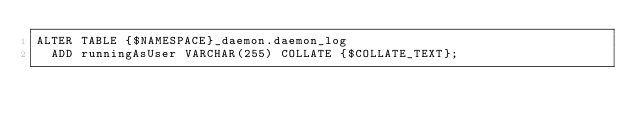<code> <loc_0><loc_0><loc_500><loc_500><_SQL_>ALTER TABLE {$NAMESPACE}_daemon.daemon_log
  ADD runningAsUser VARCHAR(255) COLLATE {$COLLATE_TEXT};
</code> 